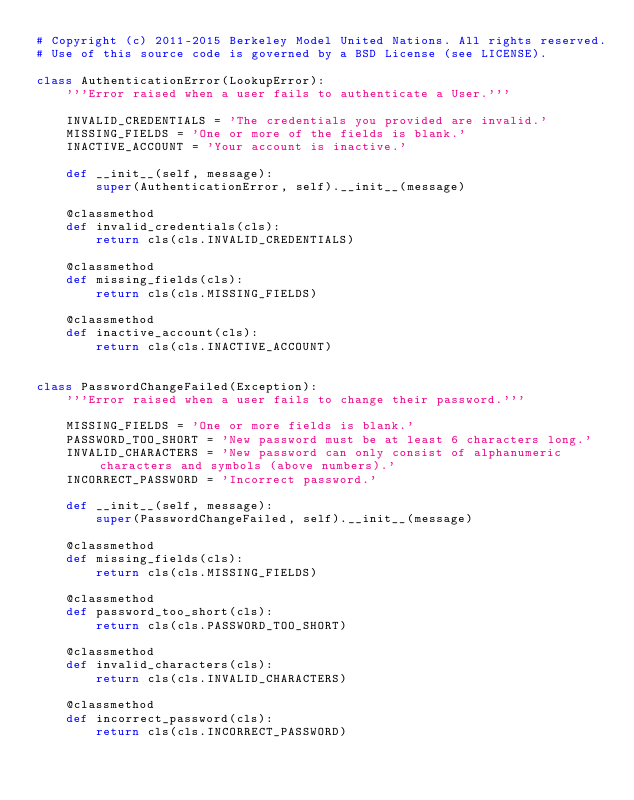<code> <loc_0><loc_0><loc_500><loc_500><_Python_># Copyright (c) 2011-2015 Berkeley Model United Nations. All rights reserved.
# Use of this source code is governed by a BSD License (see LICENSE).

class AuthenticationError(LookupError):
    '''Error raised when a user fails to authenticate a User.'''

    INVALID_CREDENTIALS = 'The credentials you provided are invalid.'
    MISSING_FIELDS = 'One or more of the fields is blank.'
    INACTIVE_ACCOUNT = 'Your account is inactive.'

    def __init__(self, message):
        super(AuthenticationError, self).__init__(message)

    @classmethod
    def invalid_credentials(cls):
        return cls(cls.INVALID_CREDENTIALS)

    @classmethod
    def missing_fields(cls):
        return cls(cls.MISSING_FIELDS)

    @classmethod
    def inactive_account(cls):
        return cls(cls.INACTIVE_ACCOUNT)


class PasswordChangeFailed(Exception):
    '''Error raised when a user fails to change their password.'''

    MISSING_FIELDS = 'One or more fields is blank.'
    PASSWORD_TOO_SHORT = 'New password must be at least 6 characters long.'
    INVALID_CHARACTERS = 'New password can only consist of alphanumeric characters and symbols (above numbers).'
    INCORRECT_PASSWORD = 'Incorrect password.'

    def __init__(self, message):
        super(PasswordChangeFailed, self).__init__(message)

    @classmethod
    def missing_fields(cls):
        return cls(cls.MISSING_FIELDS)

    @classmethod
    def password_too_short(cls):
        return cls(cls.PASSWORD_TOO_SHORT)

    @classmethod
    def invalid_characters(cls):
        return cls(cls.INVALID_CHARACTERS)

    @classmethod
    def incorrect_password(cls):
        return cls(cls.INCORRECT_PASSWORD)
</code> 